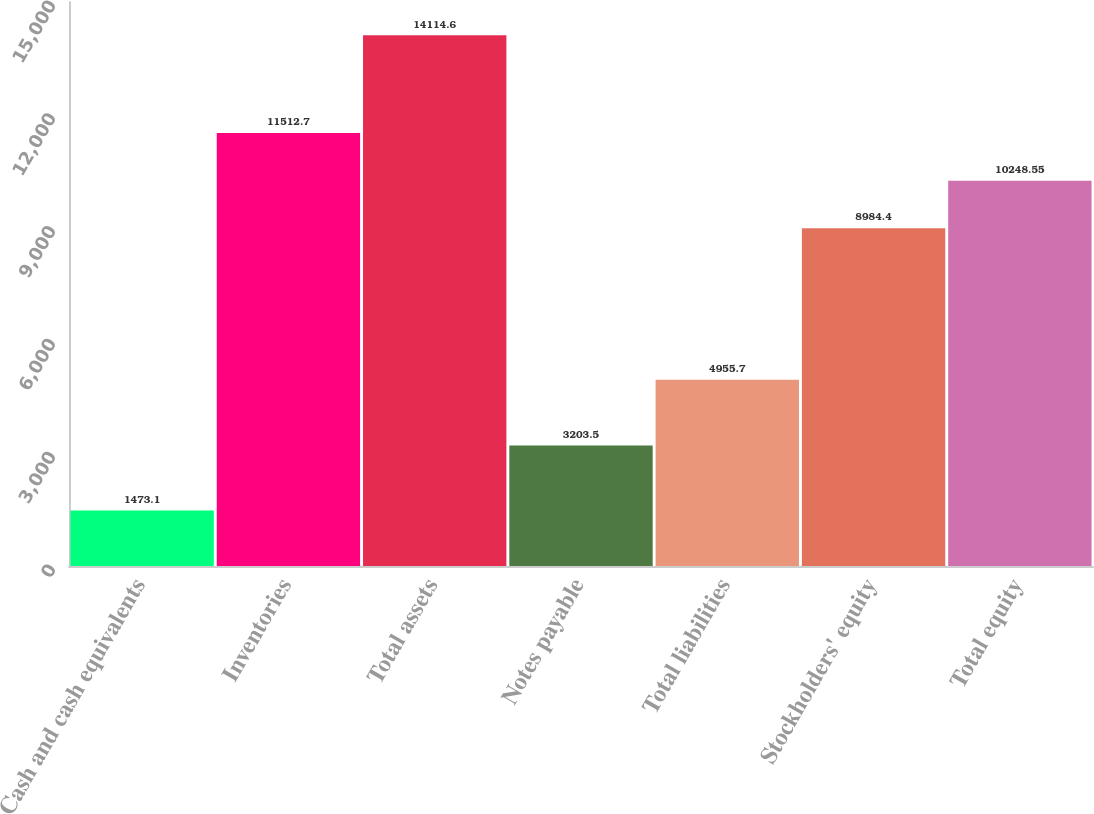Convert chart to OTSL. <chart><loc_0><loc_0><loc_500><loc_500><bar_chart><fcel>Cash and cash equivalents<fcel>Inventories<fcel>Total assets<fcel>Notes payable<fcel>Total liabilities<fcel>Stockholders' equity<fcel>Total equity<nl><fcel>1473.1<fcel>11512.7<fcel>14114.6<fcel>3203.5<fcel>4955.7<fcel>8984.4<fcel>10248.5<nl></chart> 